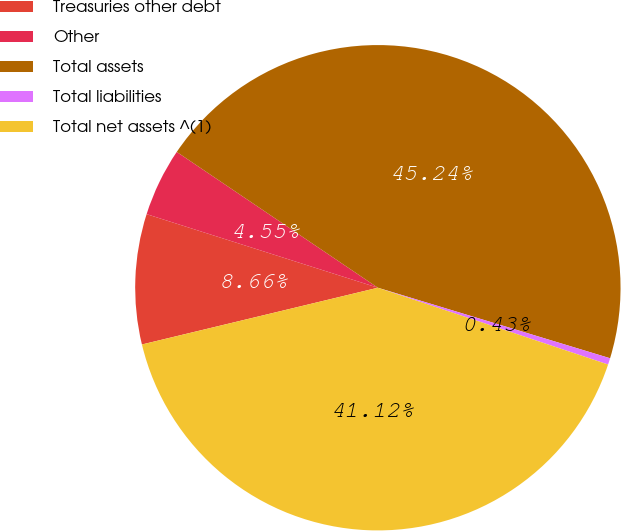Convert chart. <chart><loc_0><loc_0><loc_500><loc_500><pie_chart><fcel>Treasuries other debt<fcel>Other<fcel>Total assets<fcel>Total liabilities<fcel>Total net assets ^(1)<nl><fcel>8.66%<fcel>4.55%<fcel>45.24%<fcel>0.43%<fcel>41.12%<nl></chart> 